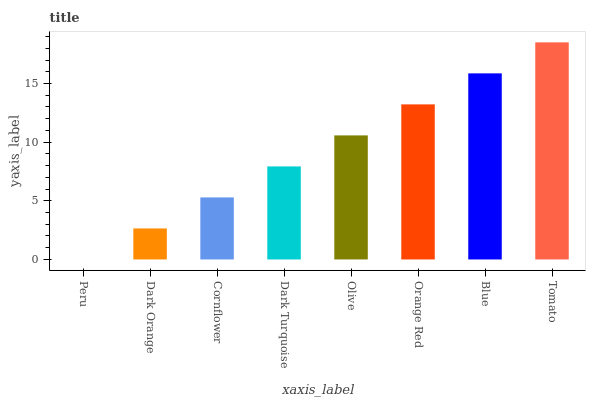Is Peru the minimum?
Answer yes or no. Yes. Is Tomato the maximum?
Answer yes or no. Yes. Is Dark Orange the minimum?
Answer yes or no. No. Is Dark Orange the maximum?
Answer yes or no. No. Is Dark Orange greater than Peru?
Answer yes or no. Yes. Is Peru less than Dark Orange?
Answer yes or no. Yes. Is Peru greater than Dark Orange?
Answer yes or no. No. Is Dark Orange less than Peru?
Answer yes or no. No. Is Olive the high median?
Answer yes or no. Yes. Is Dark Turquoise the low median?
Answer yes or no. Yes. Is Dark Turquoise the high median?
Answer yes or no. No. Is Olive the low median?
Answer yes or no. No. 